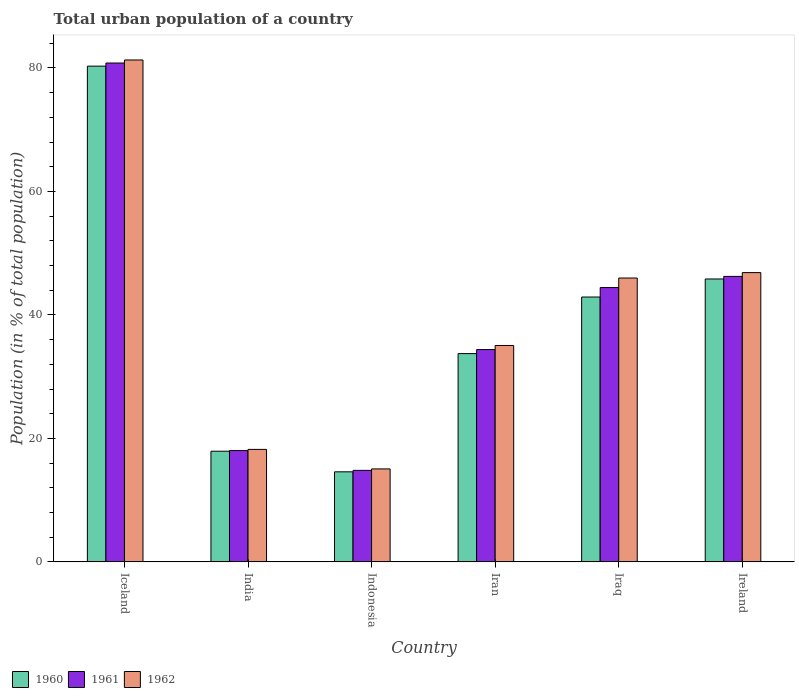Are the number of bars per tick equal to the number of legend labels?
Make the answer very short. Yes. How many bars are there on the 5th tick from the right?
Make the answer very short. 3. What is the label of the 4th group of bars from the left?
Ensure brevity in your answer.  Iran. What is the urban population in 1962 in Iraq?
Provide a succinct answer. 45.98. Across all countries, what is the maximum urban population in 1960?
Your response must be concise. 80.3. Across all countries, what is the minimum urban population in 1962?
Make the answer very short. 15.06. What is the total urban population in 1960 in the graph?
Make the answer very short. 235.27. What is the difference between the urban population in 1961 in Indonesia and that in Iran?
Your answer should be compact. -19.57. What is the difference between the urban population in 1962 in India and the urban population in 1960 in Iraq?
Your response must be concise. -24.68. What is the average urban population in 1961 per country?
Offer a terse response. 39.79. What is the difference between the urban population of/in 1962 and urban population of/in 1961 in Iran?
Your answer should be very brief. 0.66. What is the ratio of the urban population in 1962 in Iceland to that in India?
Offer a very short reply. 4.46. What is the difference between the highest and the second highest urban population in 1961?
Keep it short and to the point. 36.37. What is the difference between the highest and the lowest urban population in 1961?
Make the answer very short. 65.98. What does the 3rd bar from the right in Iceland represents?
Give a very brief answer. 1960. Is it the case that in every country, the sum of the urban population in 1960 and urban population in 1961 is greater than the urban population in 1962?
Give a very brief answer. Yes. How many bars are there?
Make the answer very short. 18. What is the difference between two consecutive major ticks on the Y-axis?
Your answer should be compact. 20. Are the values on the major ticks of Y-axis written in scientific E-notation?
Your answer should be very brief. No. Does the graph contain any zero values?
Your response must be concise. No. What is the title of the graph?
Offer a terse response. Total urban population of a country. What is the label or title of the Y-axis?
Keep it short and to the point. Population (in % of total population). What is the Population (in % of total population) in 1960 in Iceland?
Your response must be concise. 80.3. What is the Population (in % of total population) in 1961 in Iceland?
Your answer should be compact. 80.8. What is the Population (in % of total population) of 1962 in Iceland?
Keep it short and to the point. 81.3. What is the Population (in % of total population) in 1960 in India?
Keep it short and to the point. 17.92. What is the Population (in % of total population) in 1961 in India?
Provide a succinct answer. 18.03. What is the Population (in % of total population) of 1962 in India?
Your answer should be very brief. 18.22. What is the Population (in % of total population) in 1960 in Indonesia?
Provide a short and direct response. 14.59. What is the Population (in % of total population) of 1961 in Indonesia?
Your response must be concise. 14.82. What is the Population (in % of total population) in 1962 in Indonesia?
Your answer should be compact. 15.06. What is the Population (in % of total population) in 1960 in Iran?
Provide a short and direct response. 33.73. What is the Population (in % of total population) of 1961 in Iran?
Offer a terse response. 34.39. What is the Population (in % of total population) of 1962 in Iran?
Provide a succinct answer. 35.05. What is the Population (in % of total population) in 1960 in Iraq?
Make the answer very short. 42.9. What is the Population (in % of total population) of 1961 in Iraq?
Make the answer very short. 44.43. What is the Population (in % of total population) in 1962 in Iraq?
Make the answer very short. 45.98. What is the Population (in % of total population) in 1960 in Ireland?
Make the answer very short. 45.82. What is the Population (in % of total population) of 1961 in Ireland?
Ensure brevity in your answer.  46.24. What is the Population (in % of total population) of 1962 in Ireland?
Offer a terse response. 46.86. Across all countries, what is the maximum Population (in % of total population) of 1960?
Provide a short and direct response. 80.3. Across all countries, what is the maximum Population (in % of total population) of 1961?
Your answer should be very brief. 80.8. Across all countries, what is the maximum Population (in % of total population) in 1962?
Your answer should be very brief. 81.3. Across all countries, what is the minimum Population (in % of total population) in 1960?
Give a very brief answer. 14.59. Across all countries, what is the minimum Population (in % of total population) in 1961?
Offer a terse response. 14.82. Across all countries, what is the minimum Population (in % of total population) in 1962?
Offer a terse response. 15.06. What is the total Population (in % of total population) of 1960 in the graph?
Provide a short and direct response. 235.27. What is the total Population (in % of total population) in 1961 in the graph?
Give a very brief answer. 238.72. What is the total Population (in % of total population) of 1962 in the graph?
Your answer should be very brief. 242.46. What is the difference between the Population (in % of total population) in 1960 in Iceland and that in India?
Provide a short and direct response. 62.38. What is the difference between the Population (in % of total population) in 1961 in Iceland and that in India?
Your answer should be very brief. 62.77. What is the difference between the Population (in % of total population) of 1962 in Iceland and that in India?
Your answer should be compact. 63.08. What is the difference between the Population (in % of total population) in 1960 in Iceland and that in Indonesia?
Keep it short and to the point. 65.71. What is the difference between the Population (in % of total population) of 1961 in Iceland and that in Indonesia?
Your response must be concise. 65.98. What is the difference between the Population (in % of total population) of 1962 in Iceland and that in Indonesia?
Your answer should be compact. 66.24. What is the difference between the Population (in % of total population) of 1960 in Iceland and that in Iran?
Provide a succinct answer. 46.56. What is the difference between the Population (in % of total population) of 1961 in Iceland and that in Iran?
Your response must be concise. 46.41. What is the difference between the Population (in % of total population) in 1962 in Iceland and that in Iran?
Offer a very short reply. 46.25. What is the difference between the Population (in % of total population) in 1960 in Iceland and that in Iraq?
Your answer should be compact. 37.4. What is the difference between the Population (in % of total population) in 1961 in Iceland and that in Iraq?
Offer a very short reply. 36.37. What is the difference between the Population (in % of total population) of 1962 in Iceland and that in Iraq?
Ensure brevity in your answer.  35.32. What is the difference between the Population (in % of total population) of 1960 in Iceland and that in Ireland?
Offer a terse response. 34.48. What is the difference between the Population (in % of total population) in 1961 in Iceland and that in Ireland?
Your answer should be very brief. 34.56. What is the difference between the Population (in % of total population) in 1962 in Iceland and that in Ireland?
Offer a very short reply. 34.44. What is the difference between the Population (in % of total population) in 1960 in India and that in Indonesia?
Give a very brief answer. 3.34. What is the difference between the Population (in % of total population) of 1961 in India and that in Indonesia?
Give a very brief answer. 3.21. What is the difference between the Population (in % of total population) of 1962 in India and that in Indonesia?
Provide a short and direct response. 3.16. What is the difference between the Population (in % of total population) of 1960 in India and that in Iran?
Your response must be concise. -15.81. What is the difference between the Population (in % of total population) of 1961 in India and that in Iran?
Your answer should be very brief. -16.36. What is the difference between the Population (in % of total population) of 1962 in India and that in Iran?
Make the answer very short. -16.83. What is the difference between the Population (in % of total population) of 1960 in India and that in Iraq?
Your answer should be very brief. -24.98. What is the difference between the Population (in % of total population) in 1961 in India and that in Iraq?
Your response must be concise. -26.4. What is the difference between the Population (in % of total population) in 1962 in India and that in Iraq?
Your response must be concise. -27.76. What is the difference between the Population (in % of total population) of 1960 in India and that in Ireland?
Provide a short and direct response. -27.9. What is the difference between the Population (in % of total population) in 1961 in India and that in Ireland?
Ensure brevity in your answer.  -28.21. What is the difference between the Population (in % of total population) of 1962 in India and that in Ireland?
Give a very brief answer. -28.64. What is the difference between the Population (in % of total population) of 1960 in Indonesia and that in Iran?
Make the answer very short. -19.15. What is the difference between the Population (in % of total population) of 1961 in Indonesia and that in Iran?
Your answer should be very brief. -19.57. What is the difference between the Population (in % of total population) in 1962 in Indonesia and that in Iran?
Keep it short and to the point. -19.99. What is the difference between the Population (in % of total population) of 1960 in Indonesia and that in Iraq?
Provide a short and direct response. -28.31. What is the difference between the Population (in % of total population) of 1961 in Indonesia and that in Iraq?
Provide a succinct answer. -29.61. What is the difference between the Population (in % of total population) in 1962 in Indonesia and that in Iraq?
Ensure brevity in your answer.  -30.92. What is the difference between the Population (in % of total population) of 1960 in Indonesia and that in Ireland?
Ensure brevity in your answer.  -31.24. What is the difference between the Population (in % of total population) of 1961 in Indonesia and that in Ireland?
Provide a succinct answer. -31.42. What is the difference between the Population (in % of total population) of 1962 in Indonesia and that in Ireland?
Offer a terse response. -31.8. What is the difference between the Population (in % of total population) in 1960 in Iran and that in Iraq?
Offer a terse response. -9.16. What is the difference between the Population (in % of total population) of 1961 in Iran and that in Iraq?
Your response must be concise. -10.04. What is the difference between the Population (in % of total population) in 1962 in Iran and that in Iraq?
Offer a terse response. -10.93. What is the difference between the Population (in % of total population) in 1960 in Iran and that in Ireland?
Offer a very short reply. -12.09. What is the difference between the Population (in % of total population) in 1961 in Iran and that in Ireland?
Provide a succinct answer. -11.85. What is the difference between the Population (in % of total population) of 1962 in Iran and that in Ireland?
Your response must be concise. -11.8. What is the difference between the Population (in % of total population) of 1960 in Iraq and that in Ireland?
Give a very brief answer. -2.92. What is the difference between the Population (in % of total population) in 1961 in Iraq and that in Ireland?
Your answer should be very brief. -1.81. What is the difference between the Population (in % of total population) in 1962 in Iraq and that in Ireland?
Make the answer very short. -0.88. What is the difference between the Population (in % of total population) of 1960 in Iceland and the Population (in % of total population) of 1961 in India?
Your answer should be very brief. 62.27. What is the difference between the Population (in % of total population) in 1960 in Iceland and the Population (in % of total population) in 1962 in India?
Keep it short and to the point. 62.08. What is the difference between the Population (in % of total population) in 1961 in Iceland and the Population (in % of total population) in 1962 in India?
Your response must be concise. 62.59. What is the difference between the Population (in % of total population) in 1960 in Iceland and the Population (in % of total population) in 1961 in Indonesia?
Ensure brevity in your answer.  65.48. What is the difference between the Population (in % of total population) in 1960 in Iceland and the Population (in % of total population) in 1962 in Indonesia?
Your answer should be compact. 65.24. What is the difference between the Population (in % of total population) of 1961 in Iceland and the Population (in % of total population) of 1962 in Indonesia?
Make the answer very short. 65.75. What is the difference between the Population (in % of total population) of 1960 in Iceland and the Population (in % of total population) of 1961 in Iran?
Keep it short and to the point. 45.91. What is the difference between the Population (in % of total population) in 1960 in Iceland and the Population (in % of total population) in 1962 in Iran?
Your answer should be compact. 45.25. What is the difference between the Population (in % of total population) of 1961 in Iceland and the Population (in % of total population) of 1962 in Iran?
Your response must be concise. 45.75. What is the difference between the Population (in % of total population) in 1960 in Iceland and the Population (in % of total population) in 1961 in Iraq?
Provide a succinct answer. 35.87. What is the difference between the Population (in % of total population) in 1960 in Iceland and the Population (in % of total population) in 1962 in Iraq?
Your response must be concise. 34.32. What is the difference between the Population (in % of total population) of 1961 in Iceland and the Population (in % of total population) of 1962 in Iraq?
Offer a very short reply. 34.83. What is the difference between the Population (in % of total population) of 1960 in Iceland and the Population (in % of total population) of 1961 in Ireland?
Offer a terse response. 34.06. What is the difference between the Population (in % of total population) of 1960 in Iceland and the Population (in % of total population) of 1962 in Ireland?
Offer a very short reply. 33.44. What is the difference between the Population (in % of total population) in 1961 in Iceland and the Population (in % of total population) in 1962 in Ireland?
Your response must be concise. 33.95. What is the difference between the Population (in % of total population) of 1960 in India and the Population (in % of total population) of 1961 in Indonesia?
Offer a very short reply. 3.1. What is the difference between the Population (in % of total population) in 1960 in India and the Population (in % of total population) in 1962 in Indonesia?
Your response must be concise. 2.87. What is the difference between the Population (in % of total population) of 1961 in India and the Population (in % of total population) of 1962 in Indonesia?
Provide a short and direct response. 2.97. What is the difference between the Population (in % of total population) in 1960 in India and the Population (in % of total population) in 1961 in Iran?
Give a very brief answer. -16.46. What is the difference between the Population (in % of total population) of 1960 in India and the Population (in % of total population) of 1962 in Iran?
Offer a terse response. -17.13. What is the difference between the Population (in % of total population) in 1961 in India and the Population (in % of total population) in 1962 in Iran?
Your answer should be compact. -17.02. What is the difference between the Population (in % of total population) in 1960 in India and the Population (in % of total population) in 1961 in Iraq?
Ensure brevity in your answer.  -26.51. What is the difference between the Population (in % of total population) in 1960 in India and the Population (in % of total population) in 1962 in Iraq?
Keep it short and to the point. -28.05. What is the difference between the Population (in % of total population) of 1961 in India and the Population (in % of total population) of 1962 in Iraq?
Your answer should be compact. -27.95. What is the difference between the Population (in % of total population) of 1960 in India and the Population (in % of total population) of 1961 in Ireland?
Your response must be concise. -28.32. What is the difference between the Population (in % of total population) in 1960 in India and the Population (in % of total population) in 1962 in Ireland?
Keep it short and to the point. -28.93. What is the difference between the Population (in % of total population) of 1961 in India and the Population (in % of total population) of 1962 in Ireland?
Give a very brief answer. -28.82. What is the difference between the Population (in % of total population) in 1960 in Indonesia and the Population (in % of total population) in 1961 in Iran?
Your response must be concise. -19.8. What is the difference between the Population (in % of total population) in 1960 in Indonesia and the Population (in % of total population) in 1962 in Iran?
Offer a very short reply. -20.46. What is the difference between the Population (in % of total population) of 1961 in Indonesia and the Population (in % of total population) of 1962 in Iran?
Your answer should be compact. -20.23. What is the difference between the Population (in % of total population) of 1960 in Indonesia and the Population (in % of total population) of 1961 in Iraq?
Ensure brevity in your answer.  -29.85. What is the difference between the Population (in % of total population) of 1960 in Indonesia and the Population (in % of total population) of 1962 in Iraq?
Your answer should be compact. -31.39. What is the difference between the Population (in % of total population) of 1961 in Indonesia and the Population (in % of total population) of 1962 in Iraq?
Offer a terse response. -31.16. What is the difference between the Population (in % of total population) of 1960 in Indonesia and the Population (in % of total population) of 1961 in Ireland?
Make the answer very short. -31.65. What is the difference between the Population (in % of total population) of 1960 in Indonesia and the Population (in % of total population) of 1962 in Ireland?
Make the answer very short. -32.27. What is the difference between the Population (in % of total population) in 1961 in Indonesia and the Population (in % of total population) in 1962 in Ireland?
Offer a terse response. -32.03. What is the difference between the Population (in % of total population) in 1960 in Iran and the Population (in % of total population) in 1961 in Iraq?
Offer a terse response. -10.7. What is the difference between the Population (in % of total population) in 1960 in Iran and the Population (in % of total population) in 1962 in Iraq?
Give a very brief answer. -12.24. What is the difference between the Population (in % of total population) of 1961 in Iran and the Population (in % of total population) of 1962 in Iraq?
Give a very brief answer. -11.59. What is the difference between the Population (in % of total population) of 1960 in Iran and the Population (in % of total population) of 1961 in Ireland?
Provide a succinct answer. -12.51. What is the difference between the Population (in % of total population) in 1960 in Iran and the Population (in % of total population) in 1962 in Ireland?
Your response must be concise. -13.12. What is the difference between the Population (in % of total population) of 1961 in Iran and the Population (in % of total population) of 1962 in Ireland?
Offer a terse response. -12.47. What is the difference between the Population (in % of total population) in 1960 in Iraq and the Population (in % of total population) in 1961 in Ireland?
Your answer should be very brief. -3.34. What is the difference between the Population (in % of total population) in 1960 in Iraq and the Population (in % of total population) in 1962 in Ireland?
Offer a very short reply. -3.96. What is the difference between the Population (in % of total population) in 1961 in Iraq and the Population (in % of total population) in 1962 in Ireland?
Your answer should be compact. -2.42. What is the average Population (in % of total population) in 1960 per country?
Provide a succinct answer. 39.21. What is the average Population (in % of total population) in 1961 per country?
Your response must be concise. 39.79. What is the average Population (in % of total population) of 1962 per country?
Your answer should be compact. 40.41. What is the difference between the Population (in % of total population) in 1960 and Population (in % of total population) in 1961 in Iceland?
Your response must be concise. -0.5. What is the difference between the Population (in % of total population) of 1960 and Population (in % of total population) of 1962 in Iceland?
Your answer should be very brief. -1. What is the difference between the Population (in % of total population) of 1961 and Population (in % of total population) of 1962 in Iceland?
Offer a terse response. -0.49. What is the difference between the Population (in % of total population) of 1960 and Population (in % of total population) of 1961 in India?
Provide a short and direct response. -0.11. What is the difference between the Population (in % of total population) of 1960 and Population (in % of total population) of 1962 in India?
Offer a very short reply. -0.29. What is the difference between the Population (in % of total population) of 1961 and Population (in % of total population) of 1962 in India?
Keep it short and to the point. -0.19. What is the difference between the Population (in % of total population) in 1960 and Population (in % of total population) in 1961 in Indonesia?
Provide a succinct answer. -0.23. What is the difference between the Population (in % of total population) in 1960 and Population (in % of total population) in 1962 in Indonesia?
Give a very brief answer. -0.47. What is the difference between the Population (in % of total population) in 1961 and Population (in % of total population) in 1962 in Indonesia?
Provide a succinct answer. -0.24. What is the difference between the Population (in % of total population) of 1960 and Population (in % of total population) of 1961 in Iran?
Make the answer very short. -0.65. What is the difference between the Population (in % of total population) in 1960 and Population (in % of total population) in 1962 in Iran?
Make the answer very short. -1.32. What is the difference between the Population (in % of total population) in 1961 and Population (in % of total population) in 1962 in Iran?
Your answer should be compact. -0.66. What is the difference between the Population (in % of total population) in 1960 and Population (in % of total population) in 1961 in Iraq?
Provide a short and direct response. -1.53. What is the difference between the Population (in % of total population) in 1960 and Population (in % of total population) in 1962 in Iraq?
Provide a succinct answer. -3.08. What is the difference between the Population (in % of total population) of 1961 and Population (in % of total population) of 1962 in Iraq?
Offer a terse response. -1.55. What is the difference between the Population (in % of total population) of 1960 and Population (in % of total population) of 1961 in Ireland?
Offer a very short reply. -0.42. What is the difference between the Population (in % of total population) in 1960 and Population (in % of total population) in 1962 in Ireland?
Offer a terse response. -1.03. What is the difference between the Population (in % of total population) of 1961 and Population (in % of total population) of 1962 in Ireland?
Provide a succinct answer. -0.62. What is the ratio of the Population (in % of total population) in 1960 in Iceland to that in India?
Your answer should be compact. 4.48. What is the ratio of the Population (in % of total population) of 1961 in Iceland to that in India?
Give a very brief answer. 4.48. What is the ratio of the Population (in % of total population) in 1962 in Iceland to that in India?
Provide a short and direct response. 4.46. What is the ratio of the Population (in % of total population) of 1960 in Iceland to that in Indonesia?
Your response must be concise. 5.51. What is the ratio of the Population (in % of total population) in 1961 in Iceland to that in Indonesia?
Offer a terse response. 5.45. What is the ratio of the Population (in % of total population) of 1962 in Iceland to that in Indonesia?
Offer a very short reply. 5.4. What is the ratio of the Population (in % of total population) in 1960 in Iceland to that in Iran?
Offer a terse response. 2.38. What is the ratio of the Population (in % of total population) in 1961 in Iceland to that in Iran?
Your answer should be very brief. 2.35. What is the ratio of the Population (in % of total population) in 1962 in Iceland to that in Iran?
Provide a succinct answer. 2.32. What is the ratio of the Population (in % of total population) in 1960 in Iceland to that in Iraq?
Ensure brevity in your answer.  1.87. What is the ratio of the Population (in % of total population) in 1961 in Iceland to that in Iraq?
Give a very brief answer. 1.82. What is the ratio of the Population (in % of total population) in 1962 in Iceland to that in Iraq?
Make the answer very short. 1.77. What is the ratio of the Population (in % of total population) of 1960 in Iceland to that in Ireland?
Your answer should be very brief. 1.75. What is the ratio of the Population (in % of total population) of 1961 in Iceland to that in Ireland?
Ensure brevity in your answer.  1.75. What is the ratio of the Population (in % of total population) in 1962 in Iceland to that in Ireland?
Your response must be concise. 1.74. What is the ratio of the Population (in % of total population) in 1960 in India to that in Indonesia?
Your answer should be very brief. 1.23. What is the ratio of the Population (in % of total population) of 1961 in India to that in Indonesia?
Your answer should be very brief. 1.22. What is the ratio of the Population (in % of total population) in 1962 in India to that in Indonesia?
Ensure brevity in your answer.  1.21. What is the ratio of the Population (in % of total population) in 1960 in India to that in Iran?
Ensure brevity in your answer.  0.53. What is the ratio of the Population (in % of total population) of 1961 in India to that in Iran?
Provide a succinct answer. 0.52. What is the ratio of the Population (in % of total population) of 1962 in India to that in Iran?
Provide a succinct answer. 0.52. What is the ratio of the Population (in % of total population) in 1960 in India to that in Iraq?
Provide a succinct answer. 0.42. What is the ratio of the Population (in % of total population) of 1961 in India to that in Iraq?
Keep it short and to the point. 0.41. What is the ratio of the Population (in % of total population) of 1962 in India to that in Iraq?
Ensure brevity in your answer.  0.4. What is the ratio of the Population (in % of total population) of 1960 in India to that in Ireland?
Your answer should be very brief. 0.39. What is the ratio of the Population (in % of total population) of 1961 in India to that in Ireland?
Your answer should be compact. 0.39. What is the ratio of the Population (in % of total population) in 1962 in India to that in Ireland?
Your response must be concise. 0.39. What is the ratio of the Population (in % of total population) of 1960 in Indonesia to that in Iran?
Make the answer very short. 0.43. What is the ratio of the Population (in % of total population) of 1961 in Indonesia to that in Iran?
Your response must be concise. 0.43. What is the ratio of the Population (in % of total population) of 1962 in Indonesia to that in Iran?
Ensure brevity in your answer.  0.43. What is the ratio of the Population (in % of total population) in 1960 in Indonesia to that in Iraq?
Your response must be concise. 0.34. What is the ratio of the Population (in % of total population) in 1961 in Indonesia to that in Iraq?
Offer a very short reply. 0.33. What is the ratio of the Population (in % of total population) in 1962 in Indonesia to that in Iraq?
Make the answer very short. 0.33. What is the ratio of the Population (in % of total population) of 1960 in Indonesia to that in Ireland?
Your response must be concise. 0.32. What is the ratio of the Population (in % of total population) in 1961 in Indonesia to that in Ireland?
Offer a very short reply. 0.32. What is the ratio of the Population (in % of total population) of 1962 in Indonesia to that in Ireland?
Give a very brief answer. 0.32. What is the ratio of the Population (in % of total population) of 1960 in Iran to that in Iraq?
Make the answer very short. 0.79. What is the ratio of the Population (in % of total population) in 1961 in Iran to that in Iraq?
Provide a short and direct response. 0.77. What is the ratio of the Population (in % of total population) in 1962 in Iran to that in Iraq?
Offer a terse response. 0.76. What is the ratio of the Population (in % of total population) in 1960 in Iran to that in Ireland?
Offer a terse response. 0.74. What is the ratio of the Population (in % of total population) of 1961 in Iran to that in Ireland?
Your response must be concise. 0.74. What is the ratio of the Population (in % of total population) in 1962 in Iran to that in Ireland?
Ensure brevity in your answer.  0.75. What is the ratio of the Population (in % of total population) in 1960 in Iraq to that in Ireland?
Keep it short and to the point. 0.94. What is the ratio of the Population (in % of total population) in 1961 in Iraq to that in Ireland?
Offer a very short reply. 0.96. What is the ratio of the Population (in % of total population) of 1962 in Iraq to that in Ireland?
Your response must be concise. 0.98. What is the difference between the highest and the second highest Population (in % of total population) in 1960?
Provide a short and direct response. 34.48. What is the difference between the highest and the second highest Population (in % of total population) in 1961?
Give a very brief answer. 34.56. What is the difference between the highest and the second highest Population (in % of total population) of 1962?
Your answer should be very brief. 34.44. What is the difference between the highest and the lowest Population (in % of total population) of 1960?
Your response must be concise. 65.71. What is the difference between the highest and the lowest Population (in % of total population) of 1961?
Offer a terse response. 65.98. What is the difference between the highest and the lowest Population (in % of total population) in 1962?
Make the answer very short. 66.24. 